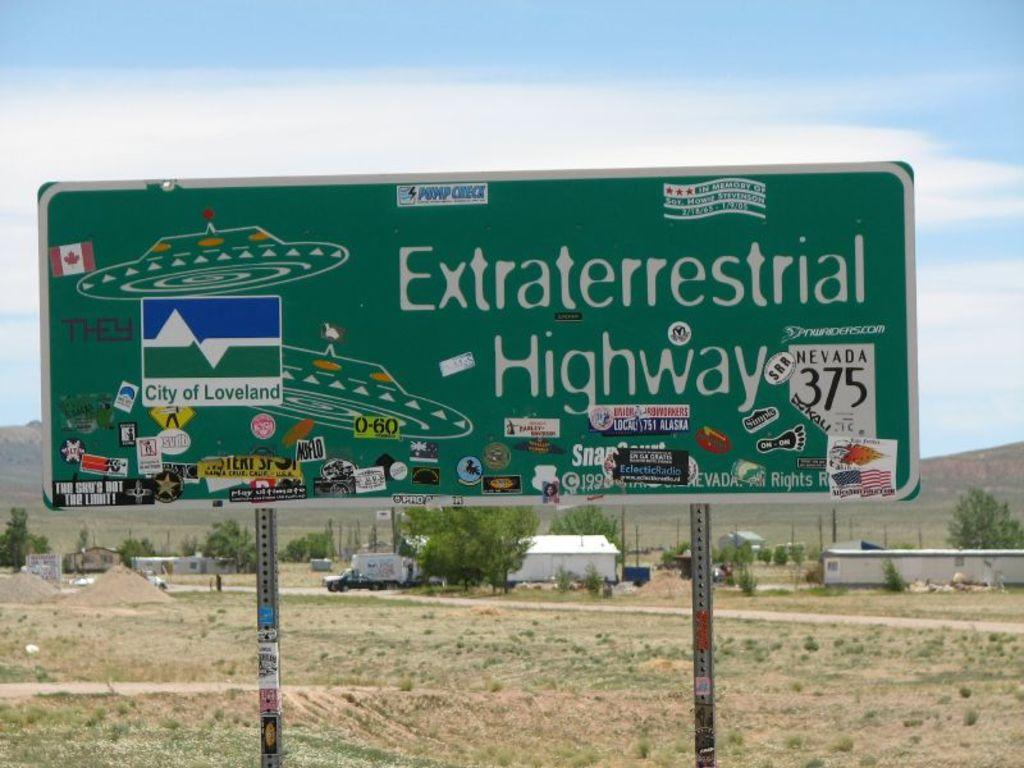Provide a one-sentence caption for the provided image. A sign that reads "Extraterrestrial Highway" with flying saucers on it. 